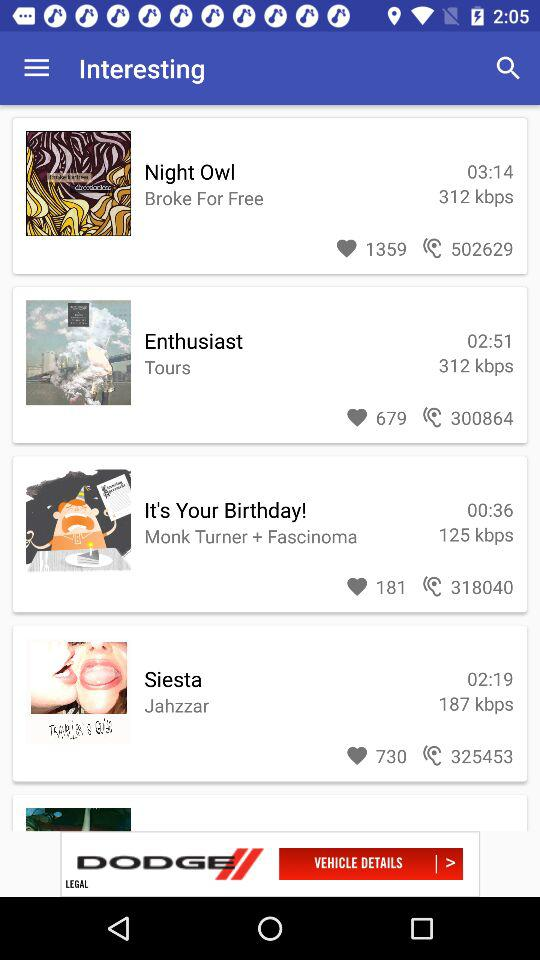How many people liked the "Enthusiast"? The number of people who liked the "Enthusiast" is 679. 